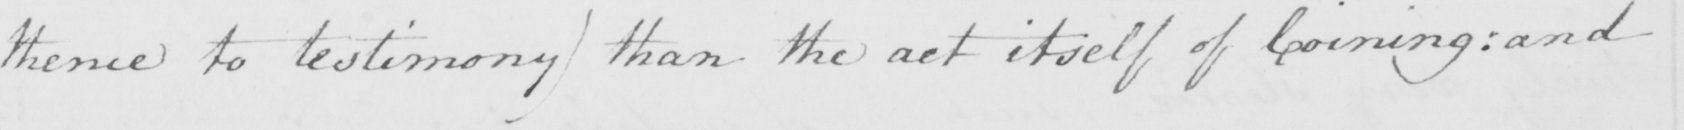Please transcribe the handwritten text in this image. thence to testimony) than the act itself of Coining: and 